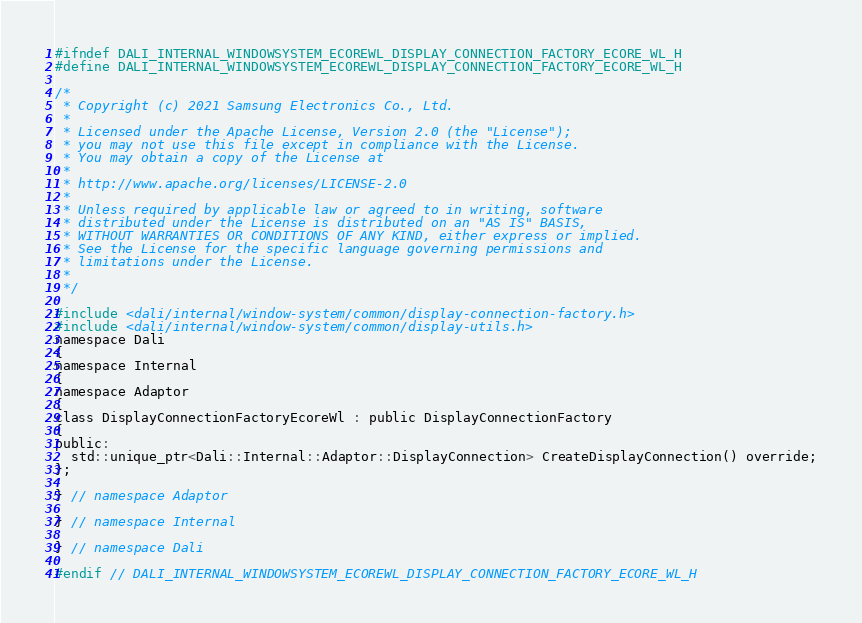Convert code to text. <code><loc_0><loc_0><loc_500><loc_500><_C_>#ifndef DALI_INTERNAL_WINDOWSYSTEM_ECOREWL_DISPLAY_CONNECTION_FACTORY_ECORE_WL_H
#define DALI_INTERNAL_WINDOWSYSTEM_ECOREWL_DISPLAY_CONNECTION_FACTORY_ECORE_WL_H

/*
 * Copyright (c) 2021 Samsung Electronics Co., Ltd.
 *
 * Licensed under the Apache License, Version 2.0 (the "License");
 * you may not use this file except in compliance with the License.
 * You may obtain a copy of the License at
 *
 * http://www.apache.org/licenses/LICENSE-2.0
 *
 * Unless required by applicable law or agreed to in writing, software
 * distributed under the License is distributed on an "AS IS" BASIS,
 * WITHOUT WARRANTIES OR CONDITIONS OF ANY KIND, either express or implied.
 * See the License for the specific language governing permissions and
 * limitations under the License.
 *
 */

#include <dali/internal/window-system/common/display-connection-factory.h>
#include <dali/internal/window-system/common/display-utils.h>
namespace Dali
{
namespace Internal
{
namespace Adaptor
{
class DisplayConnectionFactoryEcoreWl : public DisplayConnectionFactory
{
public:
  std::unique_ptr<Dali::Internal::Adaptor::DisplayConnection> CreateDisplayConnection() override;
};

} // namespace Adaptor

} // namespace Internal

} // namespace Dali

#endif // DALI_INTERNAL_WINDOWSYSTEM_ECOREWL_DISPLAY_CONNECTION_FACTORY_ECORE_WL_H
</code> 